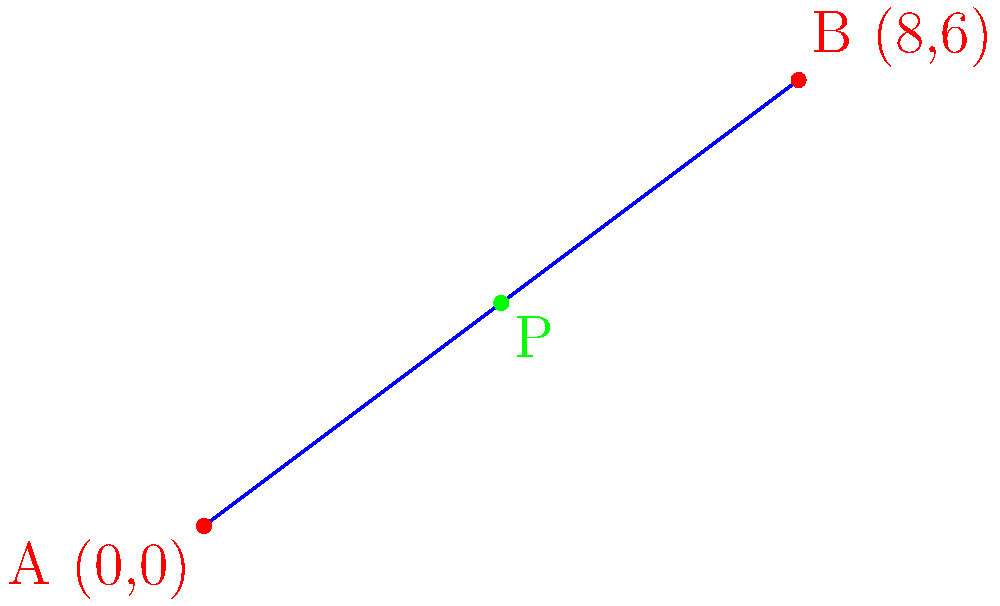On a map of historical landmarks near Florida State University, two significant sites are marked: Historical Landmark 1 at (0,0) and Historical Landmark 2 at (8,6). A heritage trail connects these two points. Find the coordinates of a point P on this trail that divides the line segment in a ratio of 1:1 (i.e., the midpoint), representing a potential location for a new historical marker. To find the coordinates of point P that divides the line segment AB in a ratio of 1:1 (midpoint), we can use the midpoint formula:

1) The midpoint formula is:
   $P_x = \frac{x_1 + x_2}{2}$ and $P_y = \frac{y_1 + y_2}{2}$

2) Given:
   A(0,0) and B(8,6)

3) Calculate $P_x$:
   $P_x = \frac{0 + 8}{2} = \frac{8}{2} = 4$

4) Calculate $P_y$:
   $P_y = \frac{0 + 6}{2} = \frac{6}{2} = 3$

5) Therefore, the coordinates of point P are (4,3).

This point represents the location on the heritage trail that is equidistant from both historical landmarks, making it an ideal spot for a new historical marker that connects the two sites.
Answer: (4,3) 